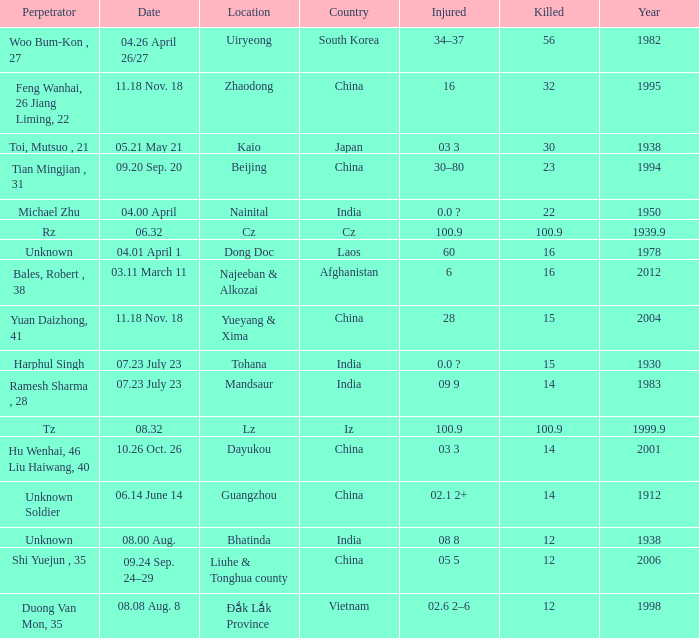What is Date, when Country is "China", and when Perpetrator is "Shi Yuejun , 35"? 09.24 Sep. 24–29. 